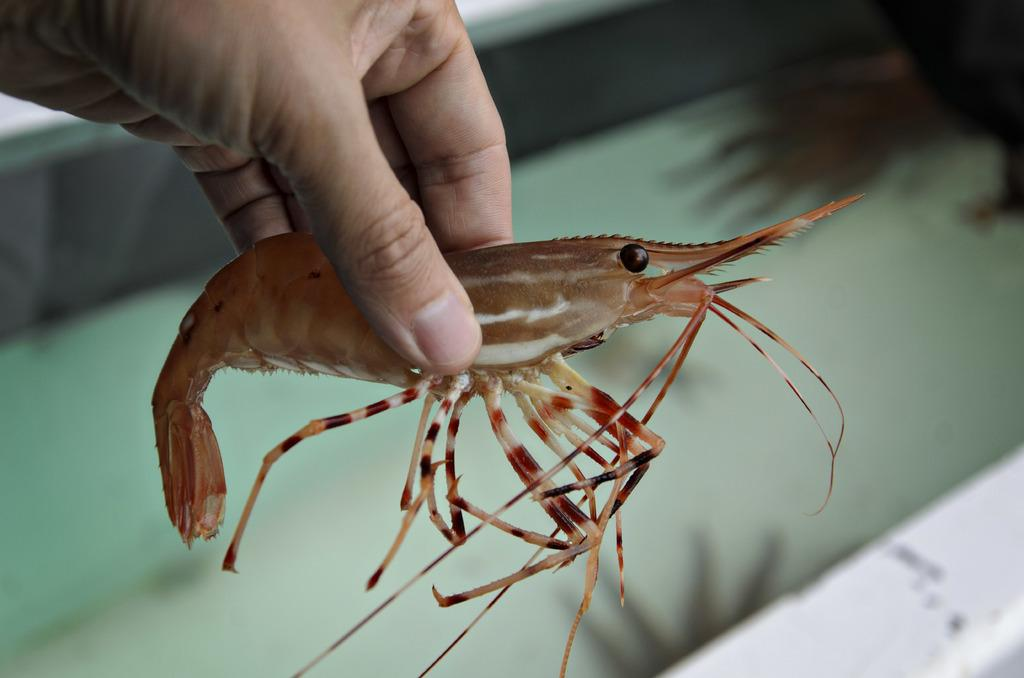What is the main subject of the image? There is a person in the image. What is the person holding in his hand? The person is holding a prawn in his hand. Can you describe the background of the image? The background of the image is blurry. What type of police equipment can be seen in the image? There is no police equipment present in the image; it features a person holding a prawn. Is there a cellar visible in the image? There is no cellar present in the image; the background is blurry. 